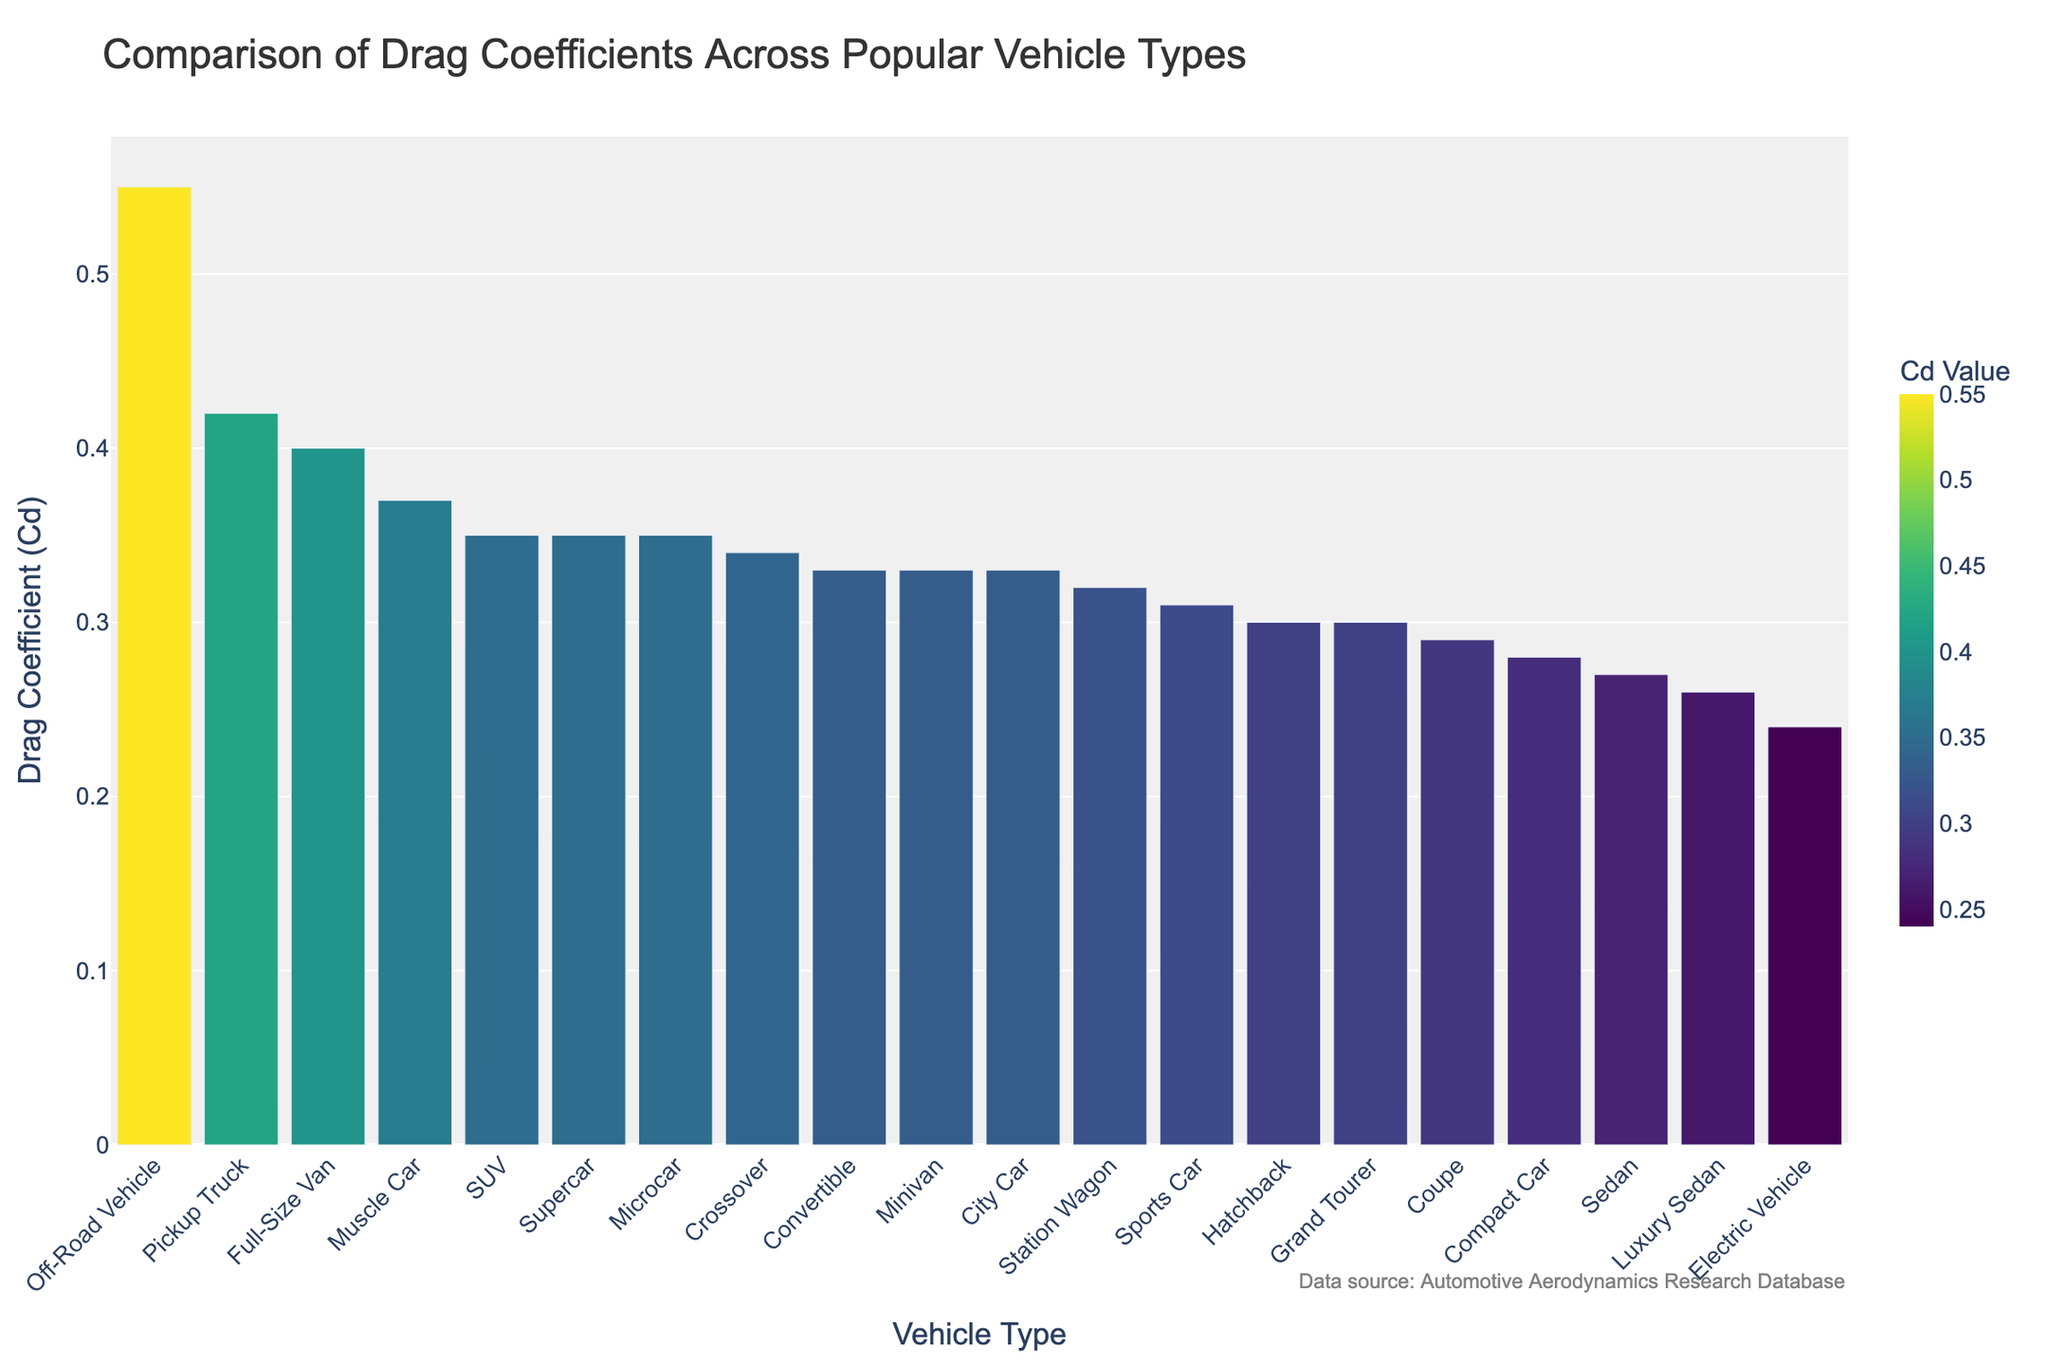What's the drag coefficient of the Sedan? The bar for the Sedan shows a drag coefficient of 0.27.
Answer: 0.27 Which vehicle type has the lowest drag coefficient? By looking at the bars, the Electric Vehicle has the lowest drag coefficient of 0.24.
Answer: Electric Vehicle Which vehicle has a higher drag coefficient, the SUV or the Sports Car? The SUV has a drag coefficient of 0.35, while the Sports Car has a drag coefficient of 0.31. Therefore, the SUV has a higher drag coefficient.
Answer: SUV What is the average drag coefficient of the Sedan, SUV, and Sports Car? Sum the drag coefficients for these vehicles: 0.27 (Sedan) + 0.35 (SUV) + 0.31 (Sports Car) = 0.93. Divide by 3 to get the average: 0.93 / 3 = 0.31.
Answer: 0.31 Which vehicle type has the highest drag coefficient? The bar for the Off-Road Vehicle shows the highest drag coefficient of 0.55.
Answer: Off-Road Vehicle How many vehicle types have a drag coefficient of exactly 0.33? By inspecting the bars, there are three vehicles with a drag coefficient of 0.33: Minivan, Convertible, and City Car.
Answer: 3 Compare the drag coefficients of the Hatchback and the Station Wagon. Which is lower? The Hatchback has a drag coefficient of 0.30, while the Station Wagon has a drag coefficient of 0.32. Therefore, the Hatchback has a lower drag coefficient.
Answer: Hatchback What is the difference in drag coefficient between the Microcar and the Luxury Sedan? The Microcar has a drag coefficient of 0.35, and the Luxury Sedan has a drag coefficient of 0.26. The difference is 0.35 - 0.26 = 0.09.
Answer: 0.09 